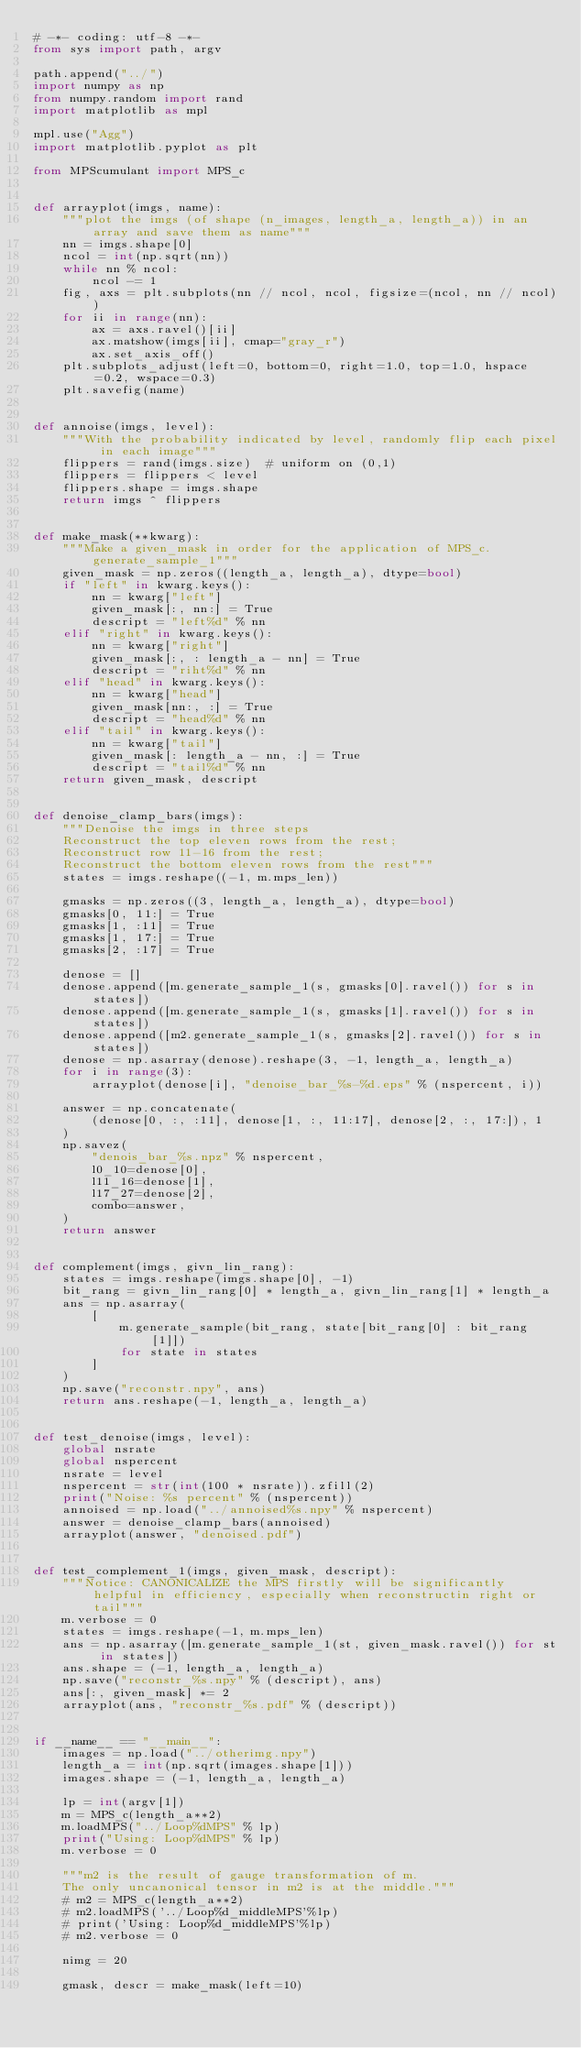Convert code to text. <code><loc_0><loc_0><loc_500><loc_500><_Python_># -*- coding: utf-8 -*-
from sys import path, argv

path.append("../")
import numpy as np
from numpy.random import rand
import matplotlib as mpl

mpl.use("Agg")
import matplotlib.pyplot as plt

from MPScumulant import MPS_c


def arrayplot(imgs, name):
    """plot the imgs (of shape (n_images, length_a, length_a)) in an array and save them as name"""
    nn = imgs.shape[0]
    ncol = int(np.sqrt(nn))
    while nn % ncol:
        ncol -= 1
    fig, axs = plt.subplots(nn // ncol, ncol, figsize=(ncol, nn // ncol))
    for ii in range(nn):
        ax = axs.ravel()[ii]
        ax.matshow(imgs[ii], cmap="gray_r")
        ax.set_axis_off()
    plt.subplots_adjust(left=0, bottom=0, right=1.0, top=1.0, hspace=0.2, wspace=0.3)
    plt.savefig(name)


def annoise(imgs, level):
    """With the probability indicated by level, randomly flip each pixel in each image"""
    flippers = rand(imgs.size)  # uniform on (0,1)
    flippers = flippers < level
    flippers.shape = imgs.shape
    return imgs ^ flippers


def make_mask(**kwarg):
    """Make a given_mask in order for the application of MPS_c.generate_sample_1"""
    given_mask = np.zeros((length_a, length_a), dtype=bool)
    if "left" in kwarg.keys():
        nn = kwarg["left"]
        given_mask[:, nn:] = True
        descript = "left%d" % nn
    elif "right" in kwarg.keys():
        nn = kwarg["right"]
        given_mask[:, : length_a - nn] = True
        descript = "riht%d" % nn
    elif "head" in kwarg.keys():
        nn = kwarg["head"]
        given_mask[nn:, :] = True
        descript = "head%d" % nn
    elif "tail" in kwarg.keys():
        nn = kwarg["tail"]
        given_mask[: length_a - nn, :] = True
        descript = "tail%d" % nn
    return given_mask, descript


def denoise_clamp_bars(imgs):
    """Denoise the imgs in three steps
    Reconstruct the top eleven rows from the rest;
    Reconstruct row 11-16 from the rest;
    Reconstruct the bottom eleven rows from the rest"""
    states = imgs.reshape((-1, m.mps_len))

    gmasks = np.zeros((3, length_a, length_a), dtype=bool)
    gmasks[0, 11:] = True
    gmasks[1, :11] = True
    gmasks[1, 17:] = True
    gmasks[2, :17] = True

    denose = []
    denose.append([m.generate_sample_1(s, gmasks[0].ravel()) for s in states])
    denose.append([m.generate_sample_1(s, gmasks[1].ravel()) for s in states])
    denose.append([m2.generate_sample_1(s, gmasks[2].ravel()) for s in states])
    denose = np.asarray(denose).reshape(3, -1, length_a, length_a)
    for i in range(3):
        arrayplot(denose[i], "denoise_bar_%s-%d.eps" % (nspercent, i))

    answer = np.concatenate(
        (denose[0, :, :11], denose[1, :, 11:17], denose[2, :, 17:]), 1
    )
    np.savez(
        "denois_bar_%s.npz" % nspercent,
        l0_10=denose[0],
        l11_16=denose[1],
        l17_27=denose[2],
        combo=answer,
    )
    return answer


def complement(imgs, givn_lin_rang):
    states = imgs.reshape(imgs.shape[0], -1)
    bit_rang = givn_lin_rang[0] * length_a, givn_lin_rang[1] * length_a
    ans = np.asarray(
        [
            m.generate_sample(bit_rang, state[bit_rang[0] : bit_rang[1]])
            for state in states
        ]
    )
    np.save("reconstr.npy", ans)
    return ans.reshape(-1, length_a, length_a)


def test_denoise(imgs, level):
    global nsrate
    global nspercent
    nsrate = level
    nspercent = str(int(100 * nsrate)).zfill(2)
    print("Noise: %s percent" % (nspercent))
    annoised = np.load("../annoised%s.npy" % nspercent)
    answer = denoise_clamp_bars(annoised)
    arrayplot(answer, "denoised.pdf")


def test_complement_1(imgs, given_mask, descript):
    """Notice: CANONICALIZE the MPS firstly will be significantly helpful in efficiency, especially when reconstructin right or tail"""
    m.verbose = 0
    states = imgs.reshape(-1, m.mps_len)
    ans = np.asarray([m.generate_sample_1(st, given_mask.ravel()) for st in states])
    ans.shape = (-1, length_a, length_a)
    np.save("reconstr_%s.npy" % (descript), ans)
    ans[:, given_mask] *= 2
    arrayplot(ans, "reconstr_%s.pdf" % (descript))


if __name__ == "__main__":
    images = np.load("../otherimg.npy")
    length_a = int(np.sqrt(images.shape[1]))
    images.shape = (-1, length_a, length_a)

    lp = int(argv[1])
    m = MPS_c(length_a**2)
    m.loadMPS("../Loop%dMPS" % lp)
    print("Using: Loop%dMPS" % lp)
    m.verbose = 0

    """m2 is the result of gauge transformation of m.
    The only uncanonical tensor in m2 is at the middle."""
    # m2 = MPS_c(length_a**2)
    # m2.loadMPS('../Loop%d_middleMPS'%lp)
    # print('Using: Loop%d_middleMPS'%lp)
    # m2.verbose = 0

    nimg = 20

    gmask, descr = make_mask(left=10)</code> 